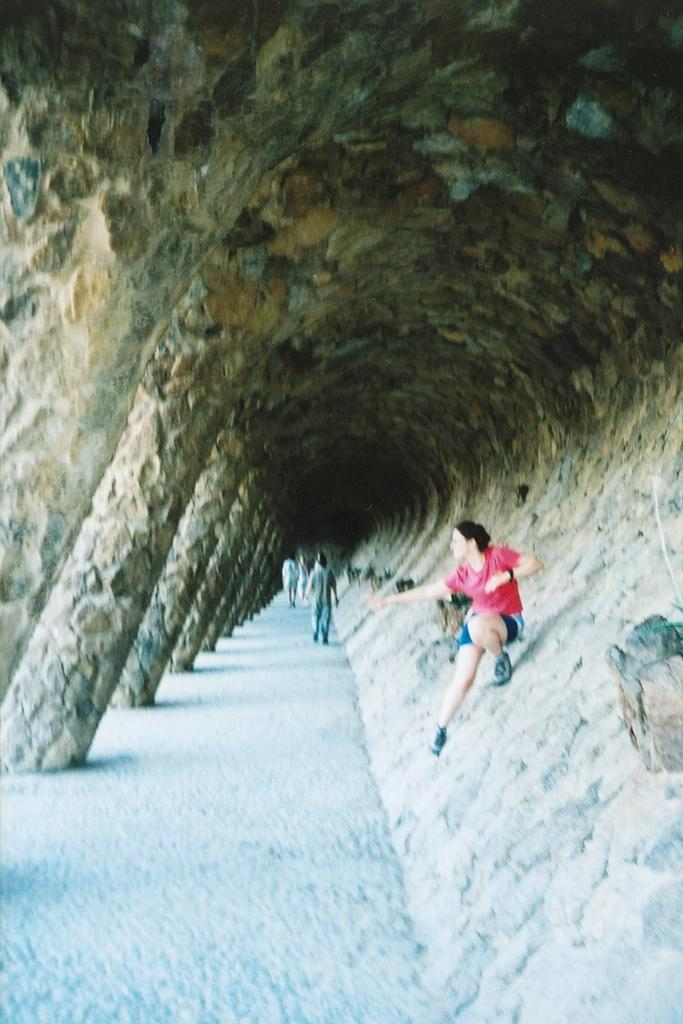What type of natural formation is present in the image? There is a cave in the image. What are the people in the image doing? The people in the image are walking in the cave. What type of engine can be seen powering the cave in the image? There is no engine present in the image, as it features a cave and people walking inside it. What word is written on the wall of the cave in the image? There is no word written on the wall of the cave in the image. 